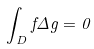Convert formula to latex. <formula><loc_0><loc_0><loc_500><loc_500>\int _ { D } f \Delta g = 0</formula> 